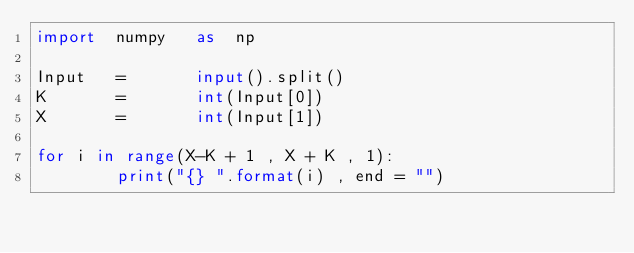Convert code to text. <code><loc_0><loc_0><loc_500><loc_500><_Python_>import  numpy   as  np

Input   =       input().split()
K       =       int(Input[0])
X       =       int(Input[1])

for i in range(X-K + 1 , X + K , 1):
        print("{} ".format(i) , end = "")</code> 